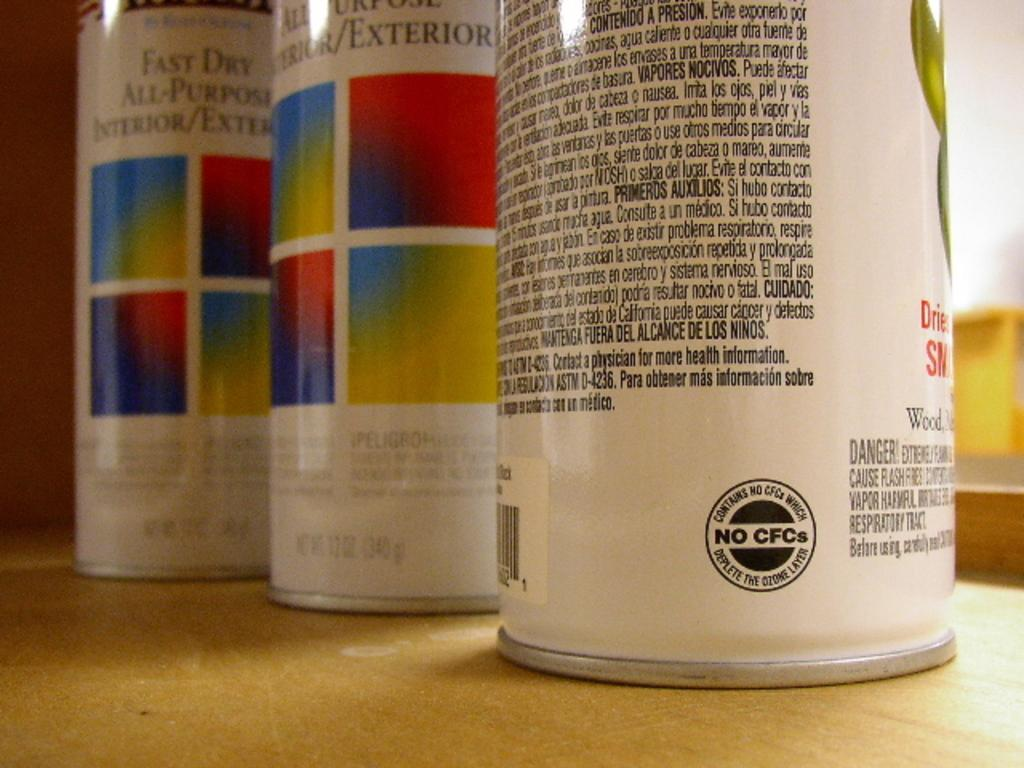<image>
Summarize the visual content of the image. The three paint tins sitting on the table have No CFCs. 